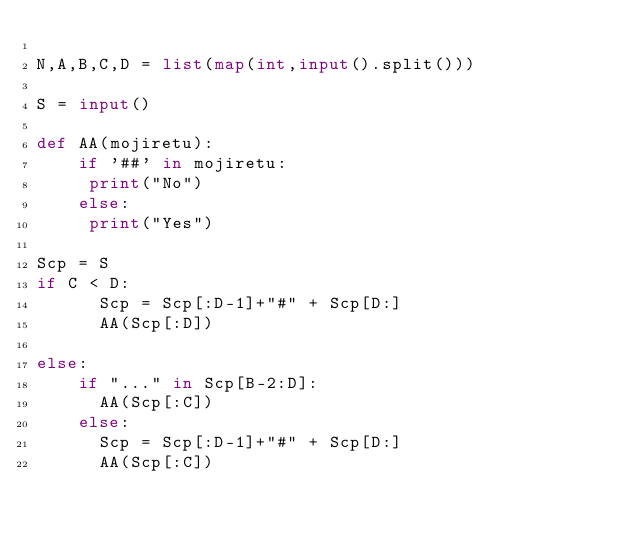Convert code to text. <code><loc_0><loc_0><loc_500><loc_500><_Python_>
N,A,B,C,D = list(map(int,input().split()))

S = input()

def AA(mojiretu):
    if '##' in mojiretu:
     print("No")
    else:
     print("Yes")

Scp = S
if C < D:
      Scp = Scp[:D-1]+"#" + Scp[D:]
      AA(Scp[:D])
      
else:
    if "..." in Scp[B-2:D]:
      AA(Scp[:C])
    else:
      Scp = Scp[:D-1]+"#" + Scp[D:]
      AA(Scp[:C])

    </code> 